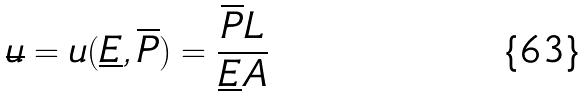Convert formula to latex. <formula><loc_0><loc_0><loc_500><loc_500>\overline { u } = u ( \underline { E } , \overline { P } ) = \frac { \overline { P } L } { \underline { E } A }</formula> 